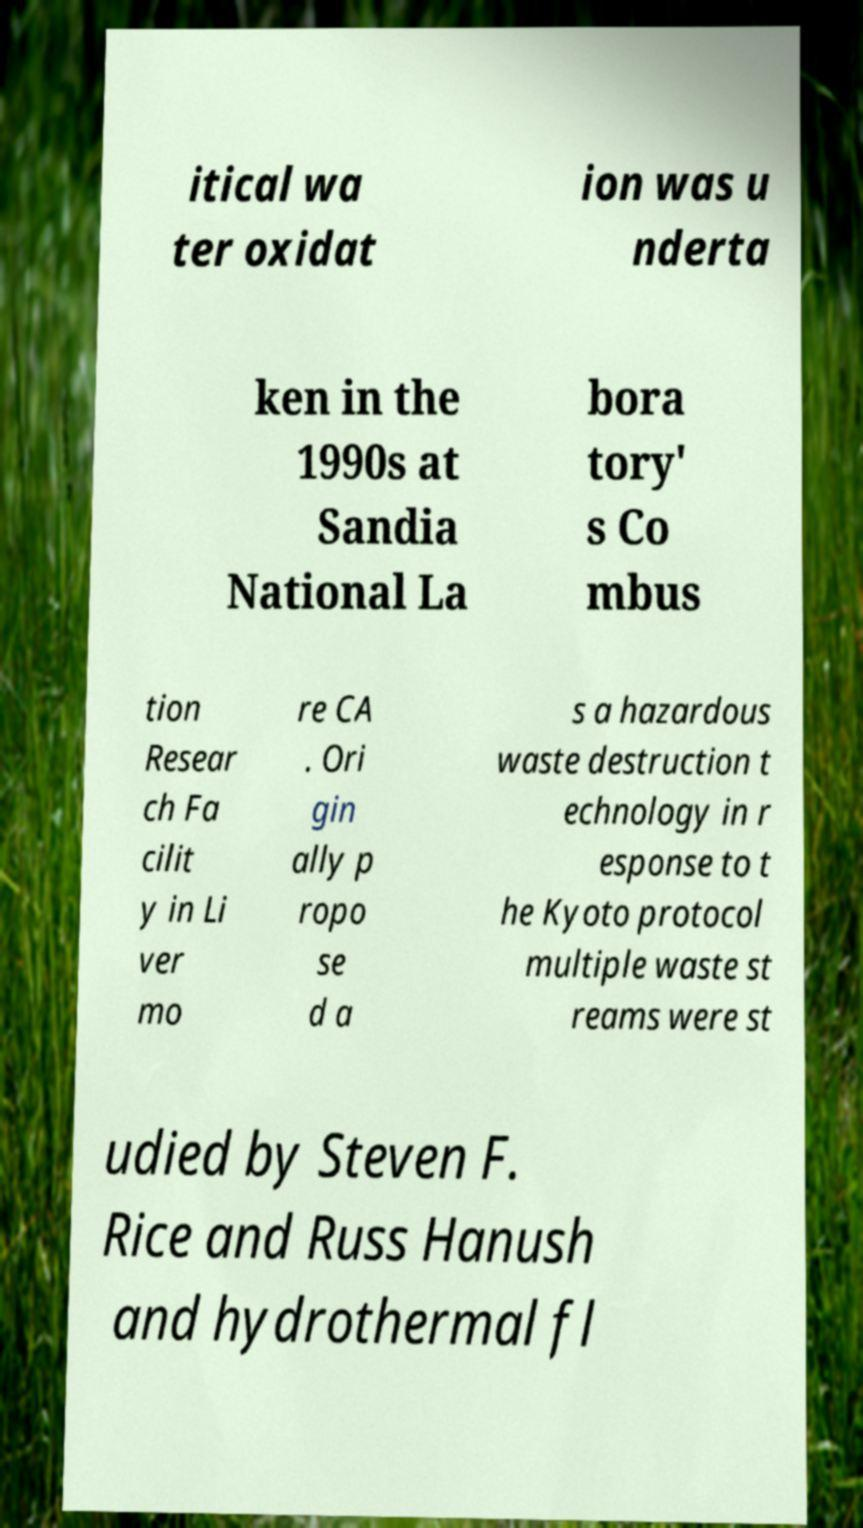Can you read and provide the text displayed in the image?This photo seems to have some interesting text. Can you extract and type it out for me? itical wa ter oxidat ion was u nderta ken in the 1990s at Sandia National La bora tory' s Co mbus tion Resear ch Fa cilit y in Li ver mo re CA . Ori gin ally p ropo se d a s a hazardous waste destruction t echnology in r esponse to t he Kyoto protocol multiple waste st reams were st udied by Steven F. Rice and Russ Hanush and hydrothermal fl 